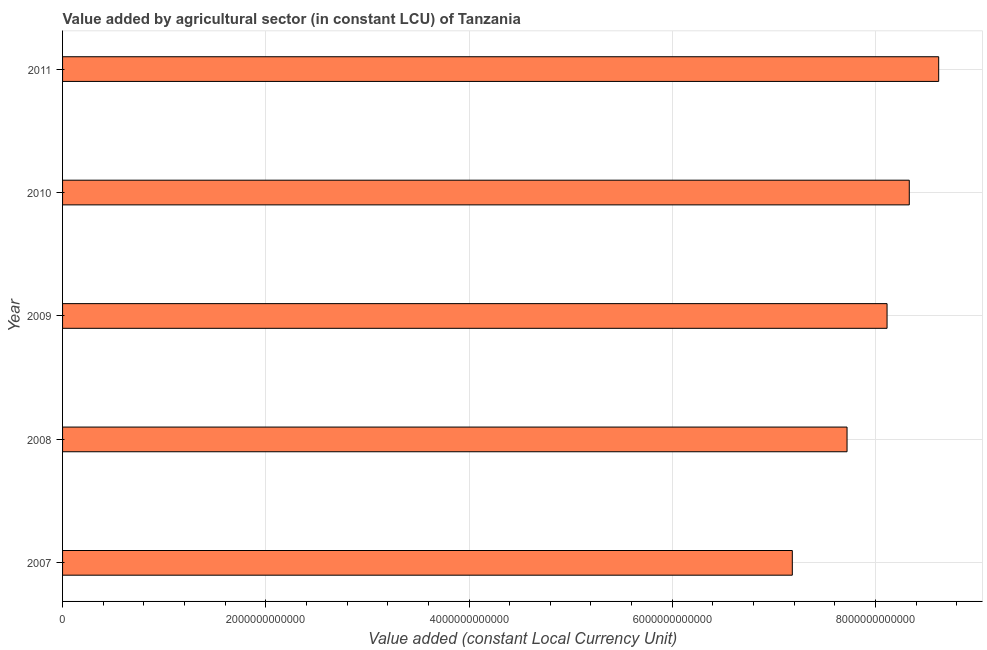Does the graph contain grids?
Offer a very short reply. Yes. What is the title of the graph?
Your answer should be compact. Value added by agricultural sector (in constant LCU) of Tanzania. What is the label or title of the X-axis?
Provide a short and direct response. Value added (constant Local Currency Unit). What is the value added by agriculture sector in 2011?
Keep it short and to the point. 8.62e+12. Across all years, what is the maximum value added by agriculture sector?
Give a very brief answer. 8.62e+12. Across all years, what is the minimum value added by agriculture sector?
Make the answer very short. 7.18e+12. In which year was the value added by agriculture sector maximum?
Keep it short and to the point. 2011. What is the sum of the value added by agriculture sector?
Provide a succinct answer. 4.00e+13. What is the difference between the value added by agriculture sector in 2007 and 2008?
Keep it short and to the point. -5.39e+11. What is the average value added by agriculture sector per year?
Provide a short and direct response. 7.99e+12. What is the median value added by agriculture sector?
Make the answer very short. 8.11e+12. Do a majority of the years between 2009 and 2011 (inclusive) have value added by agriculture sector greater than 7200000000000 LCU?
Your answer should be very brief. Yes. What is the ratio of the value added by agriculture sector in 2007 to that in 2010?
Your answer should be very brief. 0.86. Is the value added by agriculture sector in 2009 less than that in 2010?
Make the answer very short. Yes. What is the difference between the highest and the second highest value added by agriculture sector?
Your response must be concise. 2.89e+11. What is the difference between the highest and the lowest value added by agriculture sector?
Your answer should be very brief. 1.44e+12. How many bars are there?
Make the answer very short. 5. What is the difference between two consecutive major ticks on the X-axis?
Ensure brevity in your answer.  2.00e+12. What is the Value added (constant Local Currency Unit) in 2007?
Ensure brevity in your answer.  7.18e+12. What is the Value added (constant Local Currency Unit) in 2008?
Your answer should be very brief. 7.72e+12. What is the Value added (constant Local Currency Unit) of 2009?
Make the answer very short. 8.11e+12. What is the Value added (constant Local Currency Unit) in 2010?
Provide a succinct answer. 8.33e+12. What is the Value added (constant Local Currency Unit) in 2011?
Your response must be concise. 8.62e+12. What is the difference between the Value added (constant Local Currency Unit) in 2007 and 2008?
Provide a succinct answer. -5.39e+11. What is the difference between the Value added (constant Local Currency Unit) in 2007 and 2009?
Make the answer very short. -9.32e+11. What is the difference between the Value added (constant Local Currency Unit) in 2007 and 2010?
Your response must be concise. -1.15e+12. What is the difference between the Value added (constant Local Currency Unit) in 2007 and 2011?
Ensure brevity in your answer.  -1.44e+12. What is the difference between the Value added (constant Local Currency Unit) in 2008 and 2009?
Give a very brief answer. -3.94e+11. What is the difference between the Value added (constant Local Currency Unit) in 2008 and 2010?
Your answer should be compact. -6.12e+11. What is the difference between the Value added (constant Local Currency Unit) in 2008 and 2011?
Give a very brief answer. -9.02e+11. What is the difference between the Value added (constant Local Currency Unit) in 2009 and 2010?
Provide a succinct answer. -2.19e+11. What is the difference between the Value added (constant Local Currency Unit) in 2009 and 2011?
Make the answer very short. -5.08e+11. What is the difference between the Value added (constant Local Currency Unit) in 2010 and 2011?
Your answer should be compact. -2.89e+11. What is the ratio of the Value added (constant Local Currency Unit) in 2007 to that in 2008?
Provide a succinct answer. 0.93. What is the ratio of the Value added (constant Local Currency Unit) in 2007 to that in 2009?
Make the answer very short. 0.89. What is the ratio of the Value added (constant Local Currency Unit) in 2007 to that in 2010?
Give a very brief answer. 0.86. What is the ratio of the Value added (constant Local Currency Unit) in 2007 to that in 2011?
Your answer should be compact. 0.83. What is the ratio of the Value added (constant Local Currency Unit) in 2008 to that in 2009?
Offer a very short reply. 0.95. What is the ratio of the Value added (constant Local Currency Unit) in 2008 to that in 2010?
Your response must be concise. 0.93. What is the ratio of the Value added (constant Local Currency Unit) in 2008 to that in 2011?
Provide a succinct answer. 0.9. What is the ratio of the Value added (constant Local Currency Unit) in 2009 to that in 2011?
Give a very brief answer. 0.94. 